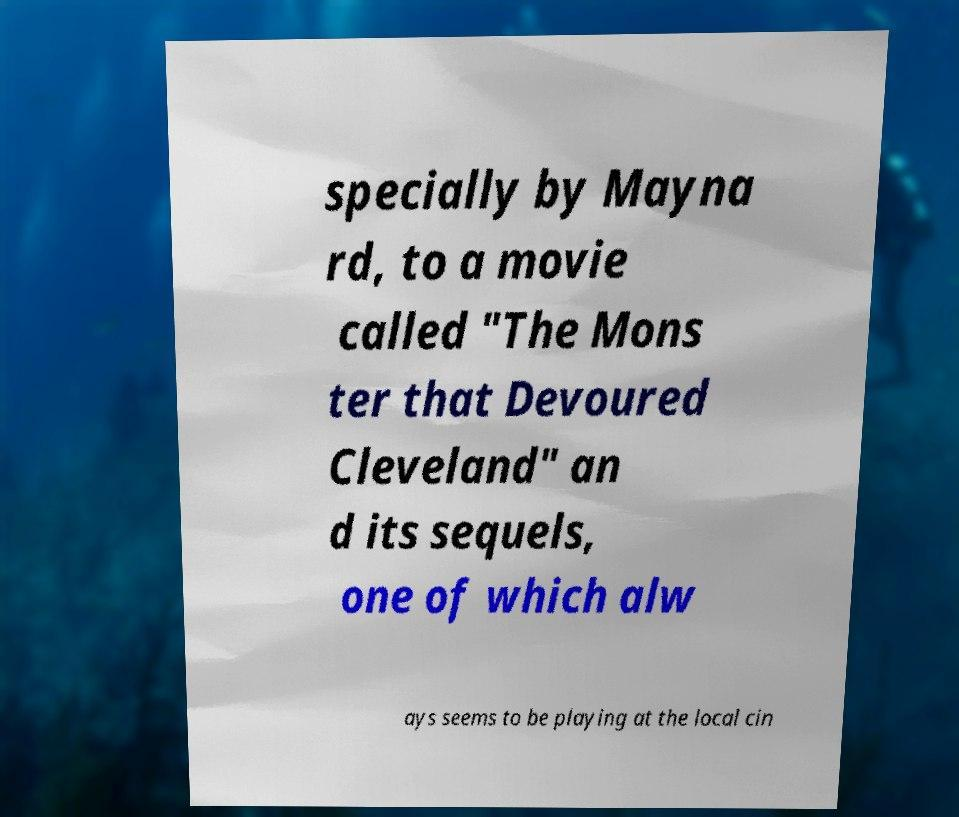What messages or text are displayed in this image? I need them in a readable, typed format. specially by Mayna rd, to a movie called "The Mons ter that Devoured Cleveland" an d its sequels, one of which alw ays seems to be playing at the local cin 